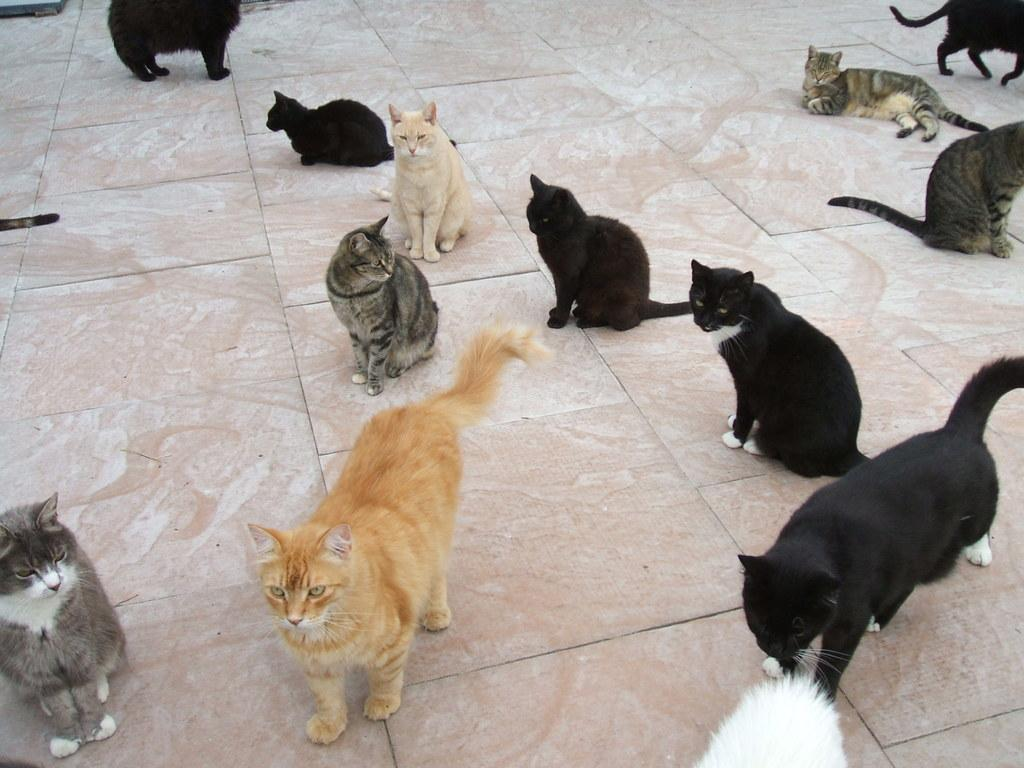How many cats are present in the image? There are multiple cats in the image. What are the cats doing in the image? Some cats are sitting, while others are standing. What colors can be seen among the cats in the image? The cats have different colors, including cream, grey, black, and white. What part of the space station can be seen in the image? There is no space station present in the image; it features multiple cats. 